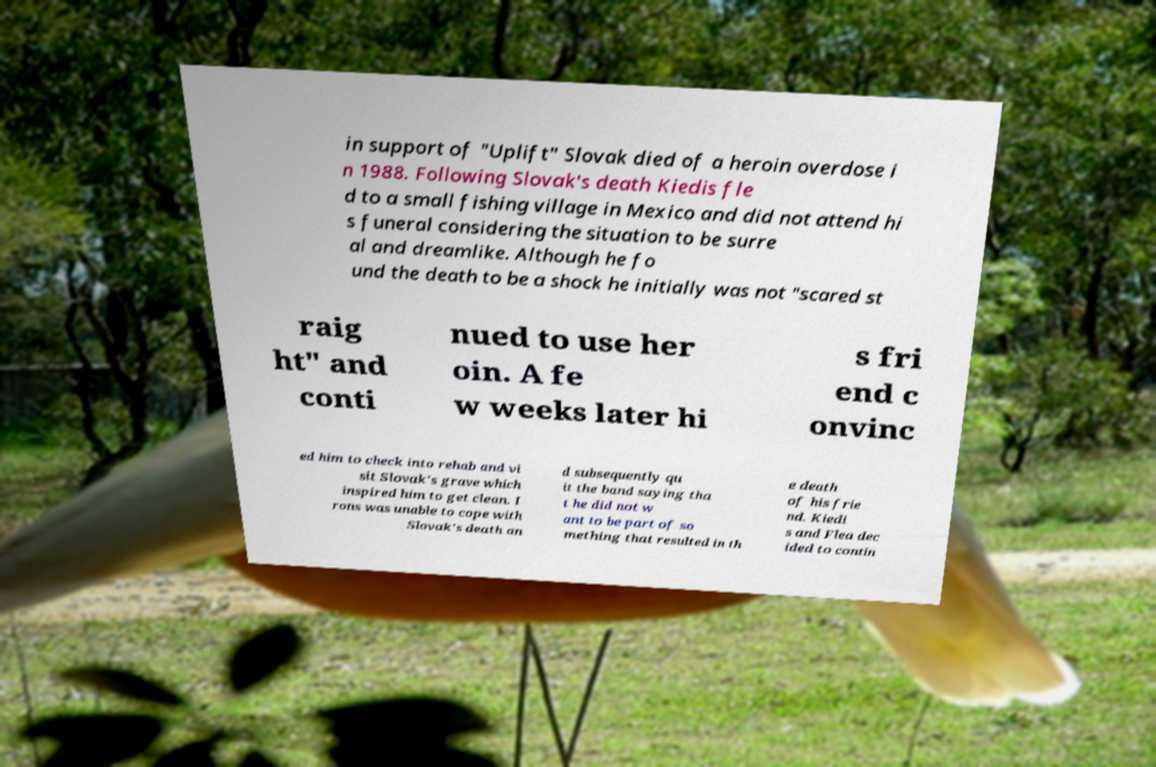Can you accurately transcribe the text from the provided image for me? in support of "Uplift" Slovak died of a heroin overdose i n 1988. Following Slovak's death Kiedis fle d to a small fishing village in Mexico and did not attend hi s funeral considering the situation to be surre al and dreamlike. Although he fo und the death to be a shock he initially was not "scared st raig ht" and conti nued to use her oin. A fe w weeks later hi s fri end c onvinc ed him to check into rehab and vi sit Slovak's grave which inspired him to get clean. I rons was unable to cope with Slovak's death an d subsequently qu it the band saying tha t he did not w ant to be part of so mething that resulted in th e death of his frie nd. Kiedi s and Flea dec ided to contin 